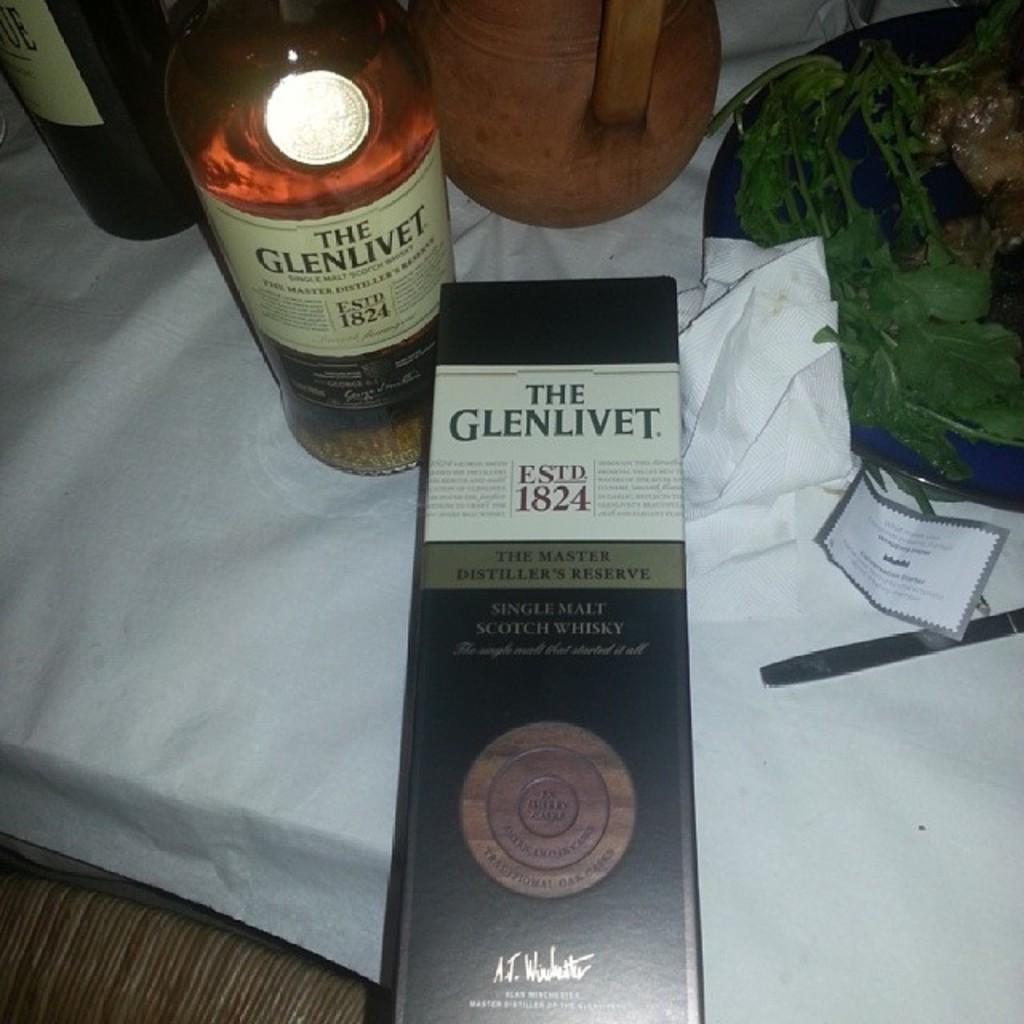<image>
Present a compact description of the photo's key features. Bottle of alcohol with a label that says The Glenlivet on it. 